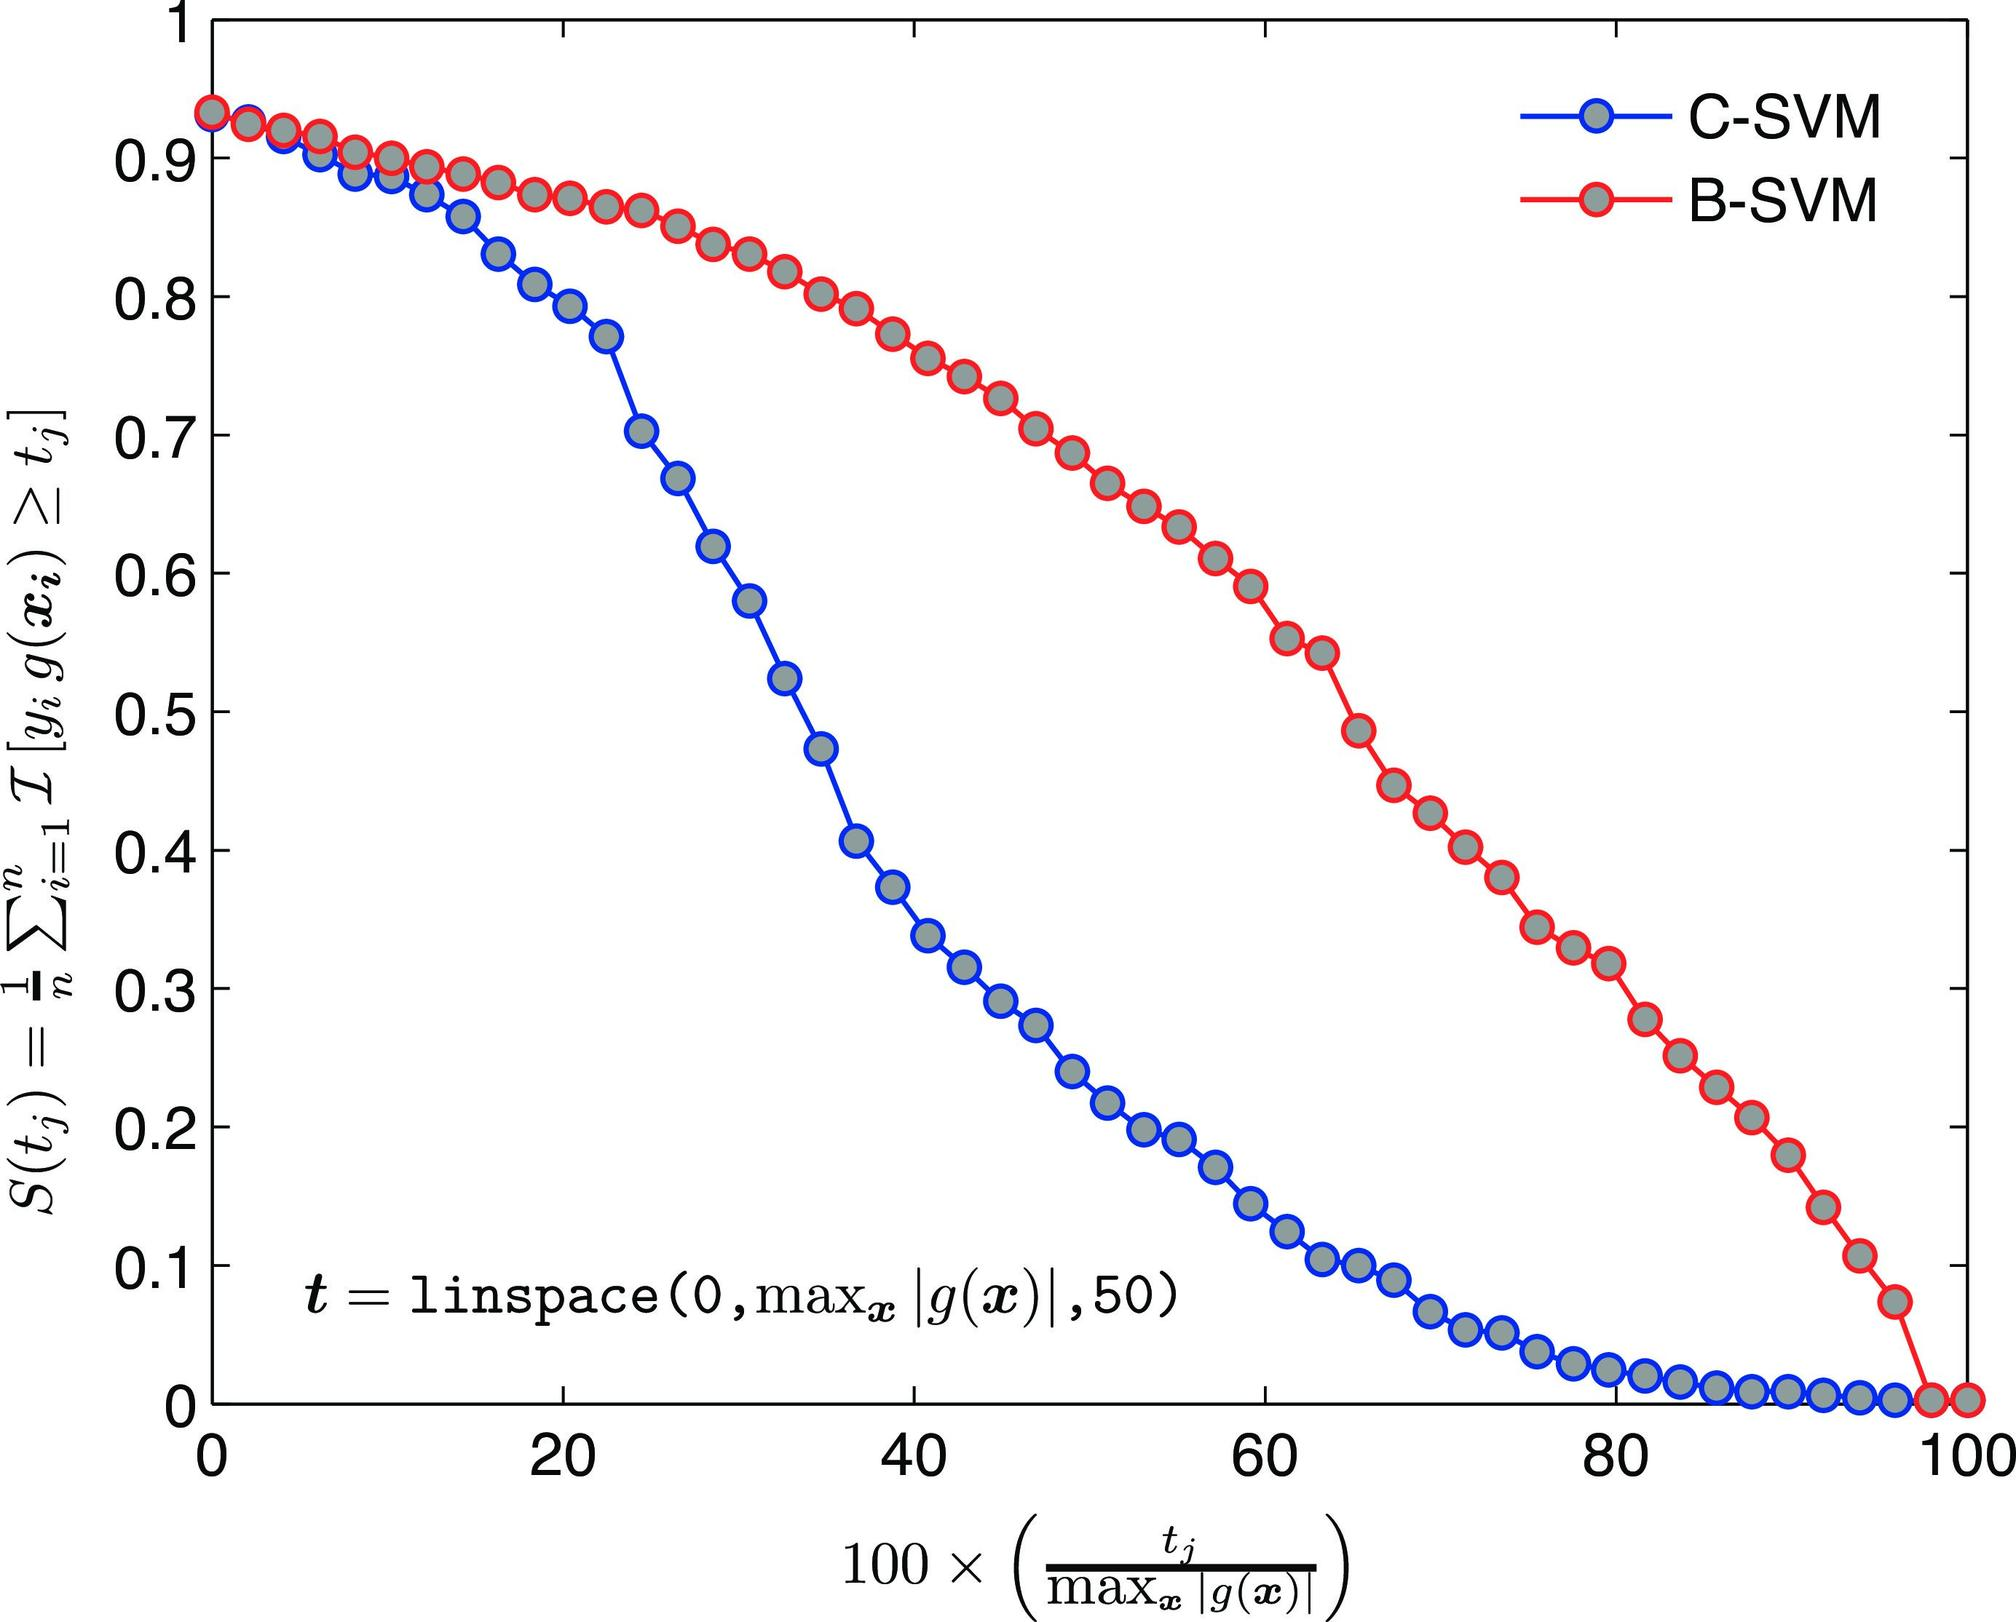Based on the figure, at approximately what value of \( t \) does B-SVM begin to outperform C-SVM? A) 20 B) 40 C) 60 D) 80 When interpreting the graph, we look for the critical point where the performance of B-SVM surpasses that of C-SVM, which is depicted as the intersection of the two curves. On examining the graph, we see that the B-SVM (illustrated by red circles) and C-SVM (blue circles) curves converge and cross just before the 40 mark. Consequently, it is after this interaction point that the B-SVM demonstrates superior performance. Hence, option B) 40 is the correct answer, representing the value of \( t \) where the transition in performance leadership occurs. 